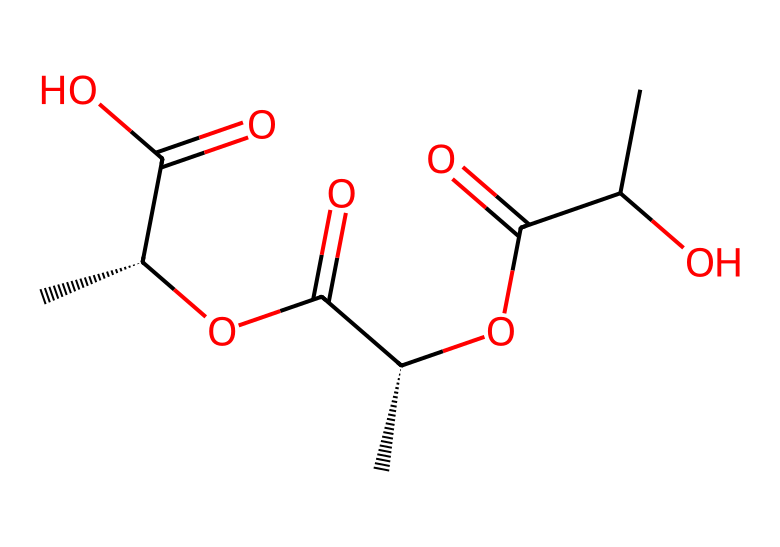What type of functional groups are present in this structure? The structure contains carboxylic acid groups, which are characterized by the -COOH group. The presence of multiple -COOH groups indicates that this polymer has acidic properties typical of biodegradable plastics.
Answer: carboxylic acid How many carbon atoms are in the polymer chain? By analyzing the SMILES representation, we can count a total of 6 carbon atoms (C). The chain structure reveals connections that include both the repeating units and terminal carbon atoms.
Answer: 6 Is this polymer likely to be biodegradable? Given the presence of carboxylic acid functional groups and ester linkages, it suggests that this polymer can be broken down by microorganisms, which is a characteristic of biodegradable plastics.
Answer: yes What is the molecular formula derived from the structure? By interpreting the SMILES notation, we can deduce that the molecular formula derived from the structure includes 6 carbon atoms, 10 hydrogen atoms, and 6 oxygen atoms, leading to the formula C6H10O6.
Answer: C6H10O6 How many ester linkages are in the polymer's structure? In the SMILES representation, the connection between the carboxylic acids and the α-hydroxyl groups indicates that there are 3 ester linkages formed, connecting different repeating units of the overall polymer structure.
Answer: 3 